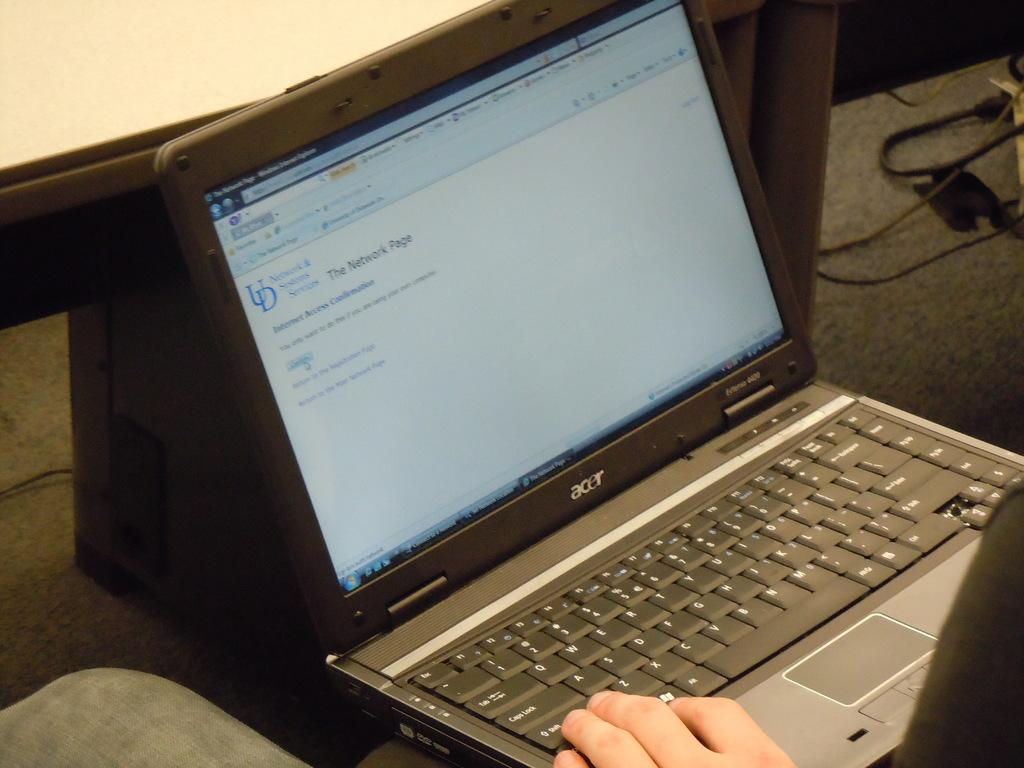<image>
Provide a brief description of the given image. A person is using an Acer laptop connected to the internet. 